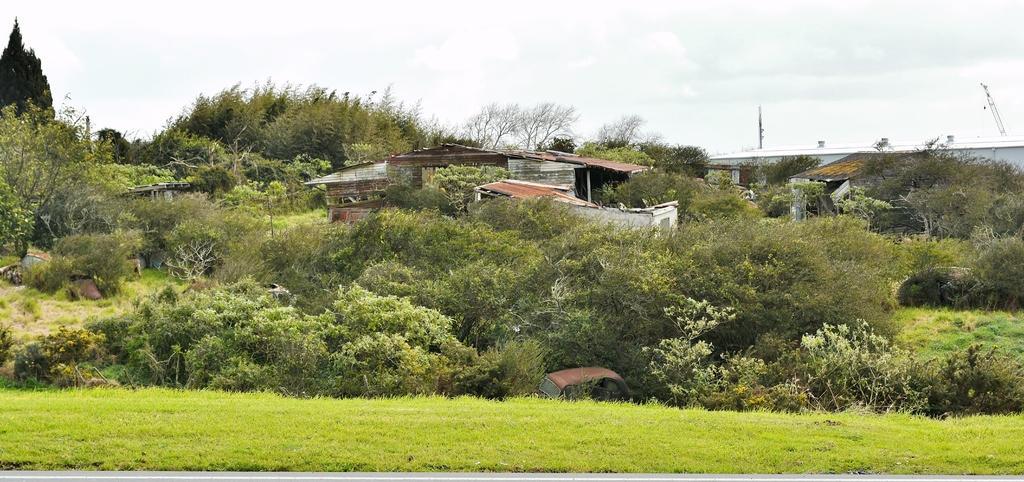Describe this image in one or two sentences. In this image, we can see trees, sheds and some plants and at the bottom, there is ground. 